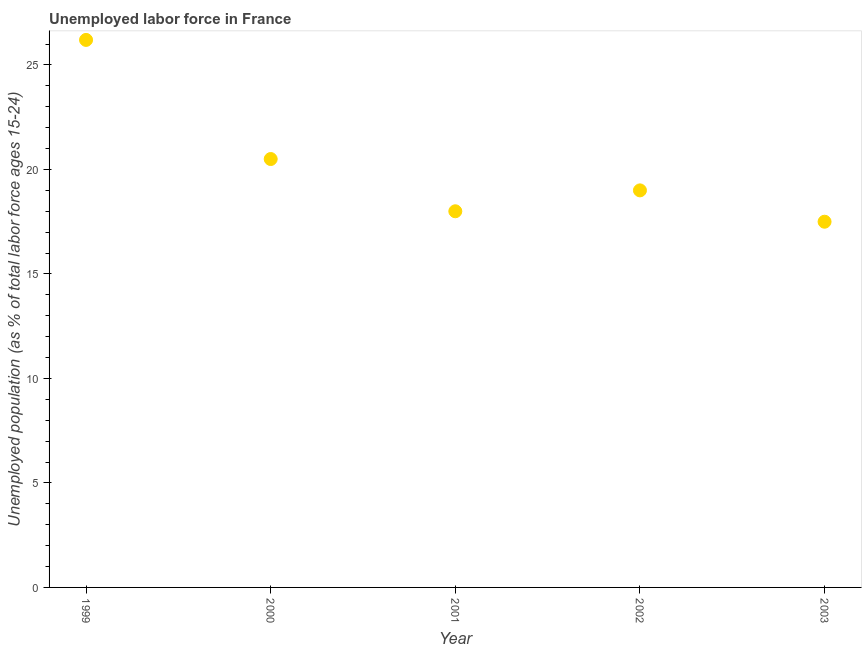Across all years, what is the maximum total unemployed youth population?
Keep it short and to the point. 26.2. In which year was the total unemployed youth population minimum?
Give a very brief answer. 2003. What is the sum of the total unemployed youth population?
Keep it short and to the point. 101.2. What is the average total unemployed youth population per year?
Ensure brevity in your answer.  20.24. What is the median total unemployed youth population?
Your answer should be compact. 19. In how many years, is the total unemployed youth population greater than 21 %?
Your answer should be very brief. 1. What is the ratio of the total unemployed youth population in 2002 to that in 2003?
Ensure brevity in your answer.  1.09. Is the total unemployed youth population in 2000 less than that in 2002?
Your answer should be very brief. No. What is the difference between the highest and the second highest total unemployed youth population?
Your response must be concise. 5.7. Is the sum of the total unemployed youth population in 2001 and 2003 greater than the maximum total unemployed youth population across all years?
Ensure brevity in your answer.  Yes. What is the difference between the highest and the lowest total unemployed youth population?
Keep it short and to the point. 8.7. Does the total unemployed youth population monotonically increase over the years?
Offer a very short reply. No. How many dotlines are there?
Your answer should be compact. 1. How many years are there in the graph?
Give a very brief answer. 5. What is the difference between two consecutive major ticks on the Y-axis?
Your response must be concise. 5. Are the values on the major ticks of Y-axis written in scientific E-notation?
Your response must be concise. No. Does the graph contain any zero values?
Offer a terse response. No. What is the title of the graph?
Offer a terse response. Unemployed labor force in France. What is the label or title of the X-axis?
Offer a very short reply. Year. What is the label or title of the Y-axis?
Offer a very short reply. Unemployed population (as % of total labor force ages 15-24). What is the Unemployed population (as % of total labor force ages 15-24) in 1999?
Provide a succinct answer. 26.2. What is the Unemployed population (as % of total labor force ages 15-24) in 2000?
Give a very brief answer. 20.5. What is the Unemployed population (as % of total labor force ages 15-24) in 2001?
Your answer should be compact. 18. What is the Unemployed population (as % of total labor force ages 15-24) in 2003?
Provide a succinct answer. 17.5. What is the difference between the Unemployed population (as % of total labor force ages 15-24) in 1999 and 2000?
Your answer should be very brief. 5.7. What is the difference between the Unemployed population (as % of total labor force ages 15-24) in 1999 and 2002?
Your answer should be very brief. 7.2. What is the difference between the Unemployed population (as % of total labor force ages 15-24) in 1999 and 2003?
Ensure brevity in your answer.  8.7. What is the difference between the Unemployed population (as % of total labor force ages 15-24) in 2000 and 2001?
Provide a succinct answer. 2.5. What is the difference between the Unemployed population (as % of total labor force ages 15-24) in 2001 and 2002?
Your answer should be compact. -1. What is the difference between the Unemployed population (as % of total labor force ages 15-24) in 2002 and 2003?
Ensure brevity in your answer.  1.5. What is the ratio of the Unemployed population (as % of total labor force ages 15-24) in 1999 to that in 2000?
Your answer should be compact. 1.28. What is the ratio of the Unemployed population (as % of total labor force ages 15-24) in 1999 to that in 2001?
Offer a very short reply. 1.46. What is the ratio of the Unemployed population (as % of total labor force ages 15-24) in 1999 to that in 2002?
Provide a succinct answer. 1.38. What is the ratio of the Unemployed population (as % of total labor force ages 15-24) in 1999 to that in 2003?
Provide a short and direct response. 1.5. What is the ratio of the Unemployed population (as % of total labor force ages 15-24) in 2000 to that in 2001?
Give a very brief answer. 1.14. What is the ratio of the Unemployed population (as % of total labor force ages 15-24) in 2000 to that in 2002?
Make the answer very short. 1.08. What is the ratio of the Unemployed population (as % of total labor force ages 15-24) in 2000 to that in 2003?
Offer a very short reply. 1.17. What is the ratio of the Unemployed population (as % of total labor force ages 15-24) in 2001 to that in 2002?
Offer a terse response. 0.95. What is the ratio of the Unemployed population (as % of total labor force ages 15-24) in 2001 to that in 2003?
Give a very brief answer. 1.03. What is the ratio of the Unemployed population (as % of total labor force ages 15-24) in 2002 to that in 2003?
Offer a terse response. 1.09. 